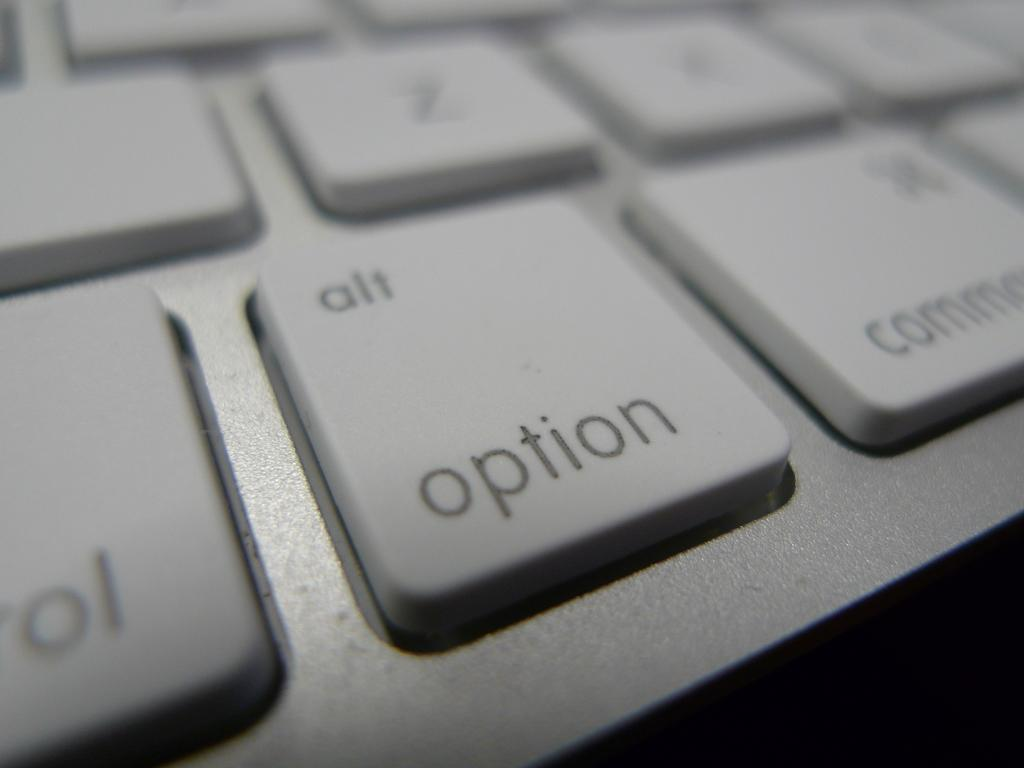<image>
Create a compact narrative representing the image presented. a white keyboard is very close, with the option button in focus 